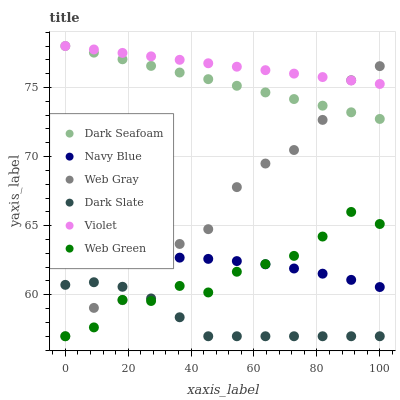Does Dark Slate have the minimum area under the curve?
Answer yes or no. Yes. Does Violet have the maximum area under the curve?
Answer yes or no. Yes. Does Navy Blue have the minimum area under the curve?
Answer yes or no. No. Does Navy Blue have the maximum area under the curve?
Answer yes or no. No. Is Dark Seafoam the smoothest?
Answer yes or no. Yes. Is Web Gray the roughest?
Answer yes or no. Yes. Is Navy Blue the smoothest?
Answer yes or no. No. Is Navy Blue the roughest?
Answer yes or no. No. Does Web Gray have the lowest value?
Answer yes or no. Yes. Does Navy Blue have the lowest value?
Answer yes or no. No. Does Violet have the highest value?
Answer yes or no. Yes. Does Navy Blue have the highest value?
Answer yes or no. No. Is Navy Blue less than Violet?
Answer yes or no. Yes. Is Violet greater than Navy Blue?
Answer yes or no. Yes. Does Web Green intersect Dark Slate?
Answer yes or no. Yes. Is Web Green less than Dark Slate?
Answer yes or no. No. Is Web Green greater than Dark Slate?
Answer yes or no. No. Does Navy Blue intersect Violet?
Answer yes or no. No. 